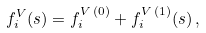<formula> <loc_0><loc_0><loc_500><loc_500>f _ { i } ^ { V } ( s ) = f _ { i } ^ { V \, ( 0 ) } + f _ { i } ^ { V \, ( 1 ) } ( s ) \, ,</formula> 